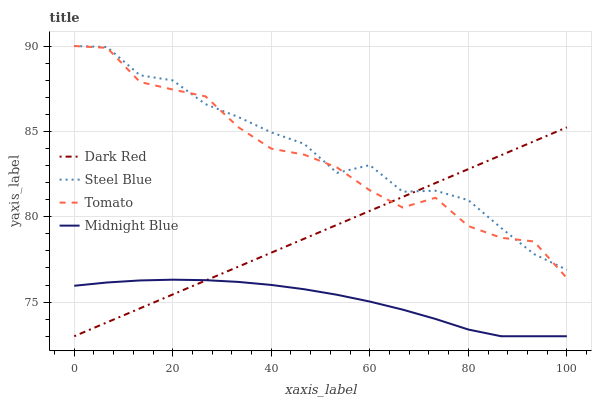Does Midnight Blue have the minimum area under the curve?
Answer yes or no. Yes. Does Steel Blue have the maximum area under the curve?
Answer yes or no. Yes. Does Dark Red have the minimum area under the curve?
Answer yes or no. No. Does Dark Red have the maximum area under the curve?
Answer yes or no. No. Is Dark Red the smoothest?
Answer yes or no. Yes. Is Tomato the roughest?
Answer yes or no. Yes. Is Steel Blue the smoothest?
Answer yes or no. No. Is Steel Blue the roughest?
Answer yes or no. No. Does Dark Red have the lowest value?
Answer yes or no. Yes. Does Steel Blue have the lowest value?
Answer yes or no. No. Does Steel Blue have the highest value?
Answer yes or no. Yes. Does Dark Red have the highest value?
Answer yes or no. No. Is Midnight Blue less than Tomato?
Answer yes or no. Yes. Is Tomato greater than Midnight Blue?
Answer yes or no. Yes. Does Tomato intersect Dark Red?
Answer yes or no. Yes. Is Tomato less than Dark Red?
Answer yes or no. No. Is Tomato greater than Dark Red?
Answer yes or no. No. Does Midnight Blue intersect Tomato?
Answer yes or no. No. 